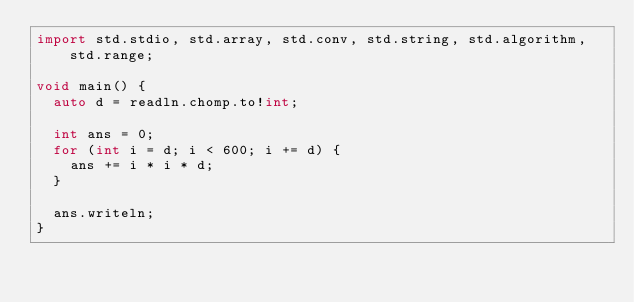<code> <loc_0><loc_0><loc_500><loc_500><_D_>import std.stdio, std.array, std.conv, std.string, std.algorithm, std.range;

void main() {
  auto d = readln.chomp.to!int;

  int ans = 0;
  for (int i = d; i < 600; i += d) {
    ans += i * i * d;
  }

  ans.writeln;
}</code> 